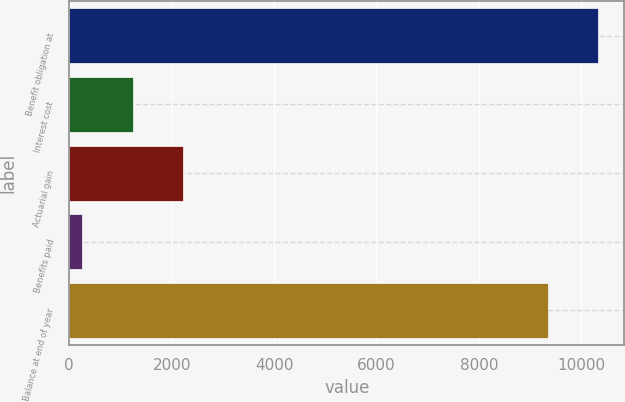Convert chart. <chart><loc_0><loc_0><loc_500><loc_500><bar_chart><fcel>Benefit obligation at<fcel>Interest cost<fcel>Actuarial gain<fcel>Benefits paid<fcel>Balance at end of year<nl><fcel>10326.1<fcel>1237.1<fcel>2217.2<fcel>257<fcel>9346<nl></chart> 